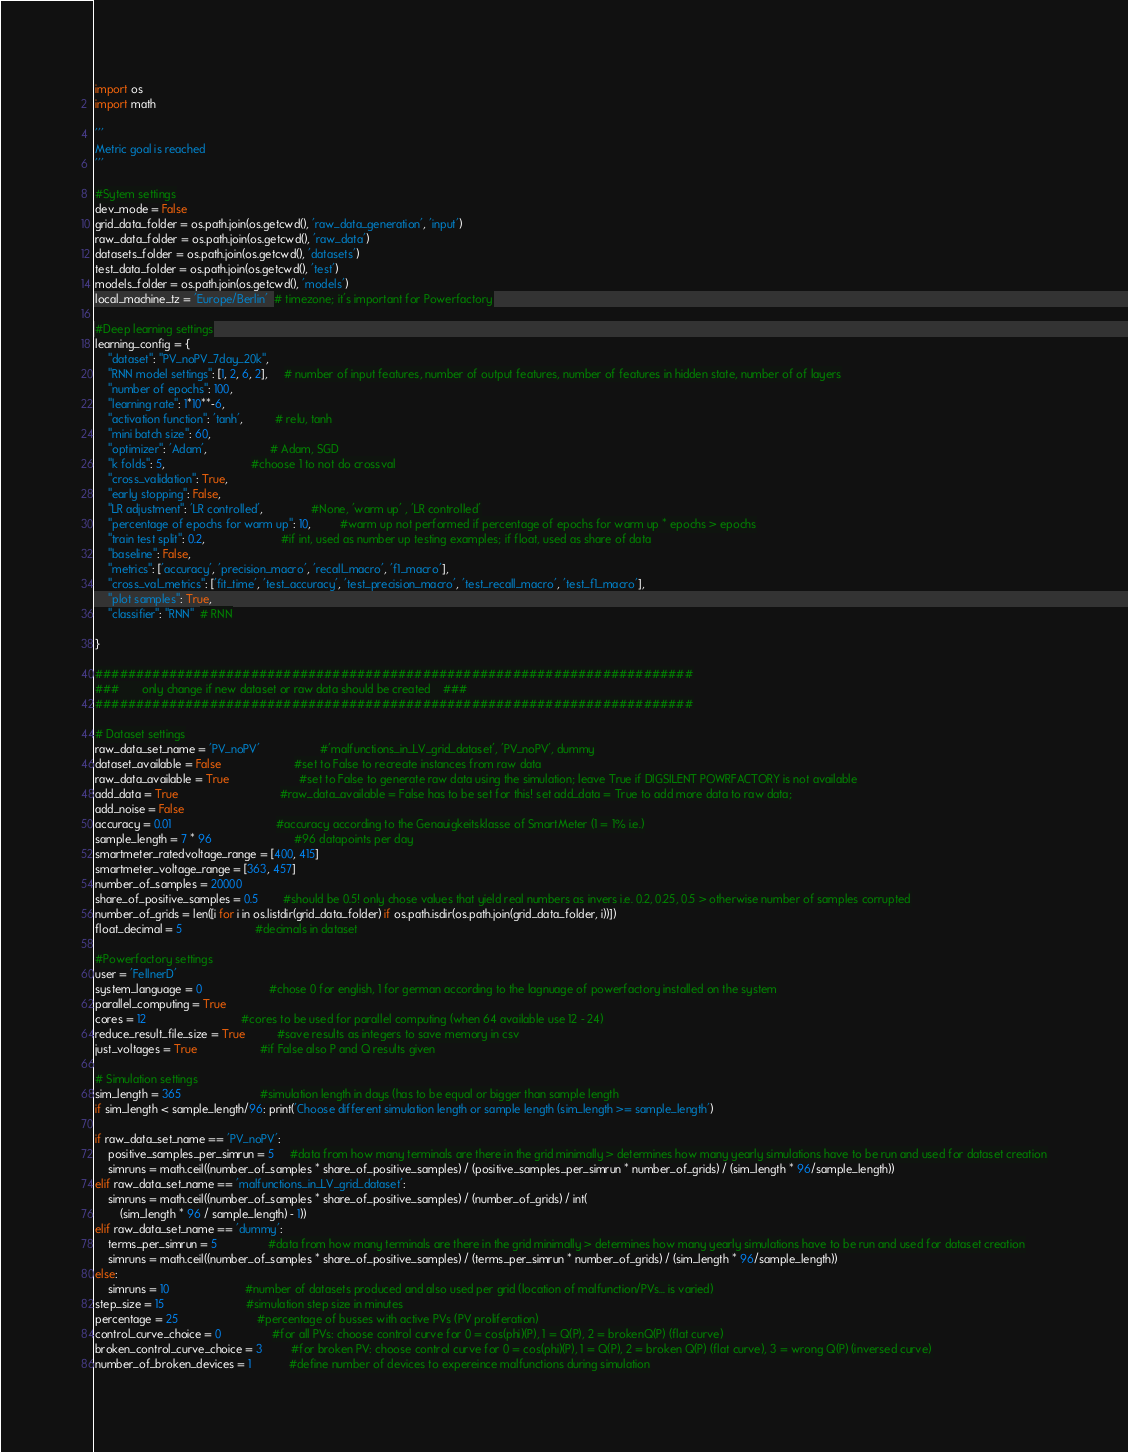Convert code to text. <code><loc_0><loc_0><loc_500><loc_500><_Python_>import os
import math

'''
Metric goal is reached
'''

#Sytem settings
dev_mode = False
grid_data_folder = os.path.join(os.getcwd(), 'raw_data_generation', 'input')
raw_data_folder = os.path.join(os.getcwd(), 'raw_data')
datasets_folder = os.path.join(os.getcwd(), 'datasets')
test_data_folder = os.path.join(os.getcwd(), 'test')
models_folder = os.path.join(os.getcwd(), 'models')
local_machine_tz = 'Europe/Berlin'  # timezone; it's important for Powerfactory

#Deep learning settings
learning_config = {
    "dataset": "PV_noPV_7day_20k",
    "RNN model settings": [1, 2, 6, 2],     # number of input features, number of output features, number of features in hidden state, number of of layers
    "number of epochs": 100,
    "learning rate": 1*10**-6,
    "activation function": 'tanh',          # relu, tanh
    "mini batch size": 60,
    "optimizer": 'Adam',                    # Adam, SGD
    "k folds": 5,                           #choose 1 to not do crossval
    "cross_validation": True,
    "early stopping": False,
    "LR adjustment": 'LR controlled',               #None, 'warm up' , 'LR controlled'
    "percentage of epochs for warm up": 10,         #warm up not performed if percentage of epochs for warm up * epochs > epochs
    "train test split": 0.2,                        #if int, used as number up testing examples; if float, used as share of data
    "baseline": False,
    "metrics": ['accuracy', 'precision_macro', 'recall_macro', 'f1_macro'],
    "cross_val_metrics": ['fit_time', 'test_accuracy', 'test_precision_macro', 'test_recall_macro', 'test_f1_macro'],
    "plot samples": True,
    "classifier": "RNN"  # RNN

}

#########################################################################
###       only change if new dataset or raw data should be created    ###
#########################################################################

# Dataset settings
raw_data_set_name = 'PV_noPV'                   #'malfunctions_in_LV_grid_dataset', 'PV_noPV', dummy
dataset_available = False                       #set to False to recreate instances from raw data
raw_data_available = True                      #set to False to generate raw data using the simulation; leave True if DIGSILENT POWRFACTORY is not available
add_data = True                                #raw_data_available = False has to be set for this! set add_data = True to add more data to raw data;
add_noise = False
accuracy = 0.01                                 #accuracy according to the Genauigkeitsklasse of SmartMeter (1 = 1% i.e.)
sample_length = 7 * 96                          #96 datapoints per day
smartmeter_ratedvoltage_range = [400, 415]
smartmeter_voltage_range = [363, 457]
number_of_samples = 20000
share_of_positive_samples = 0.5        #should be 0.5! only chose values that yield real numbers as invers i.e. 0.2, 0.25, 0.5 > otherwise number of samples corrupted
number_of_grids = len([i for i in os.listdir(grid_data_folder) if os.path.isdir(os.path.join(grid_data_folder, i))])
float_decimal = 5                       #decimals in dataset

#Powerfactory settings
user = 'FellnerD'
system_language = 0                     #chose 0 for english, 1 for german according to the lagnuage of powerfactory installed on the system
parallel_computing = True
cores = 12                              #cores to be used for parallel computing (when 64 available use 12 - 24)
reduce_result_file_size = True          #save results as integers to save memory in csv
just_voltages = True                    #if False also P and Q results given

# Simulation settings
sim_length = 365                         #simulation length in days (has to be equal or bigger than sample length
if sim_length < sample_length/96: print('Choose different simulation length or sample length (sim_length >= sample_length')

if raw_data_set_name == 'PV_noPV':
    positive_samples_per_simrun = 5     #data from how many terminals are there in the grid minimally > determines how many yearly simulations have to be run and used for dataset creation
    simruns = math.ceil((number_of_samples * share_of_positive_samples) / (positive_samples_per_simrun * number_of_grids) / (sim_length * 96/sample_length))
elif raw_data_set_name == 'malfunctions_in_LV_grid_dataset':
    simruns = math.ceil((number_of_samples * share_of_positive_samples) / (number_of_grids) / int(
        (sim_length * 96 / sample_length) - 1))
elif raw_data_set_name == 'dummy':
    terms_per_simrun = 5                #data from how many terminals are there in the grid minimally > determines how many yearly simulations have to be run and used for dataset creation
    simruns = math.ceil((number_of_samples * share_of_positive_samples) / (terms_per_simrun * number_of_grids) / (sim_length * 96/sample_length))
else:
    simruns = 10                        #number of datasets produced and also used per grid (location of malfunction/PVs... is varied)
step_size = 15                          #simulation step size in minutes
percentage = 25                         #percentage of busses with active PVs (PV proliferation)
control_curve_choice = 0                #for all PVs: choose control curve for 0 = cos(phi)(P), 1 = Q(P), 2 = brokenQ(P) (flat curve)
broken_control_curve_choice = 3         #for broken PV: choose control curve for 0 = cos(phi)(P), 1 = Q(P), 2 = broken Q(P) (flat curve), 3 = wrong Q(P) (inversed curve)
number_of_broken_devices = 1            #define number of devices to expereince malfunctions during simulation</code> 